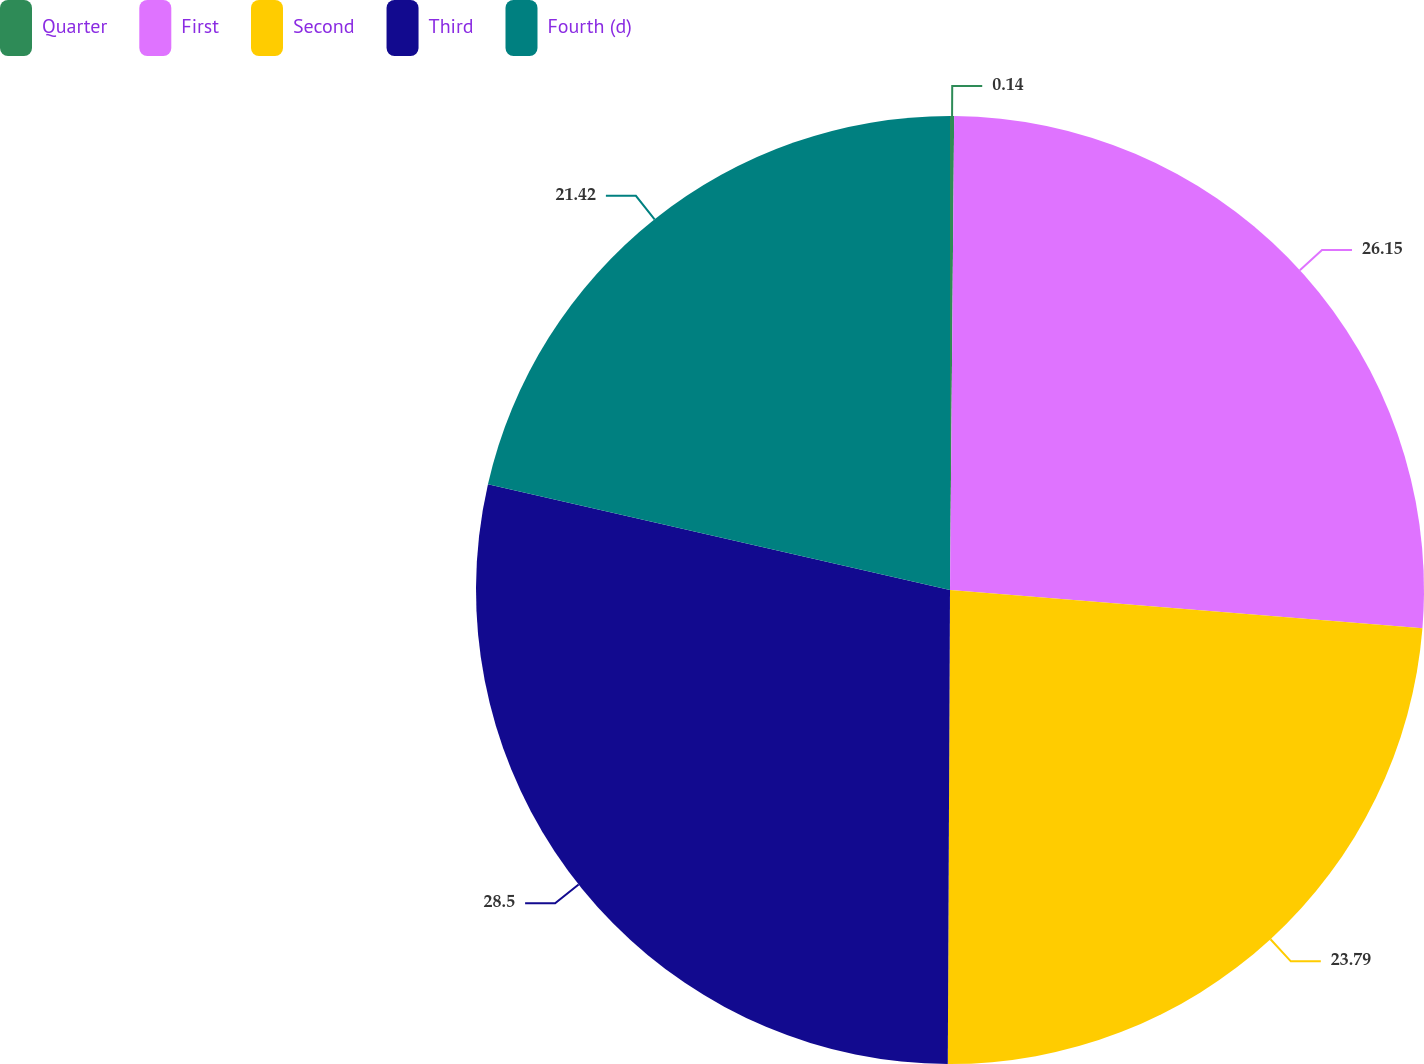Convert chart to OTSL. <chart><loc_0><loc_0><loc_500><loc_500><pie_chart><fcel>Quarter<fcel>First<fcel>Second<fcel>Third<fcel>Fourth (d)<nl><fcel>0.14%<fcel>26.15%<fcel>23.79%<fcel>28.51%<fcel>21.42%<nl></chart> 